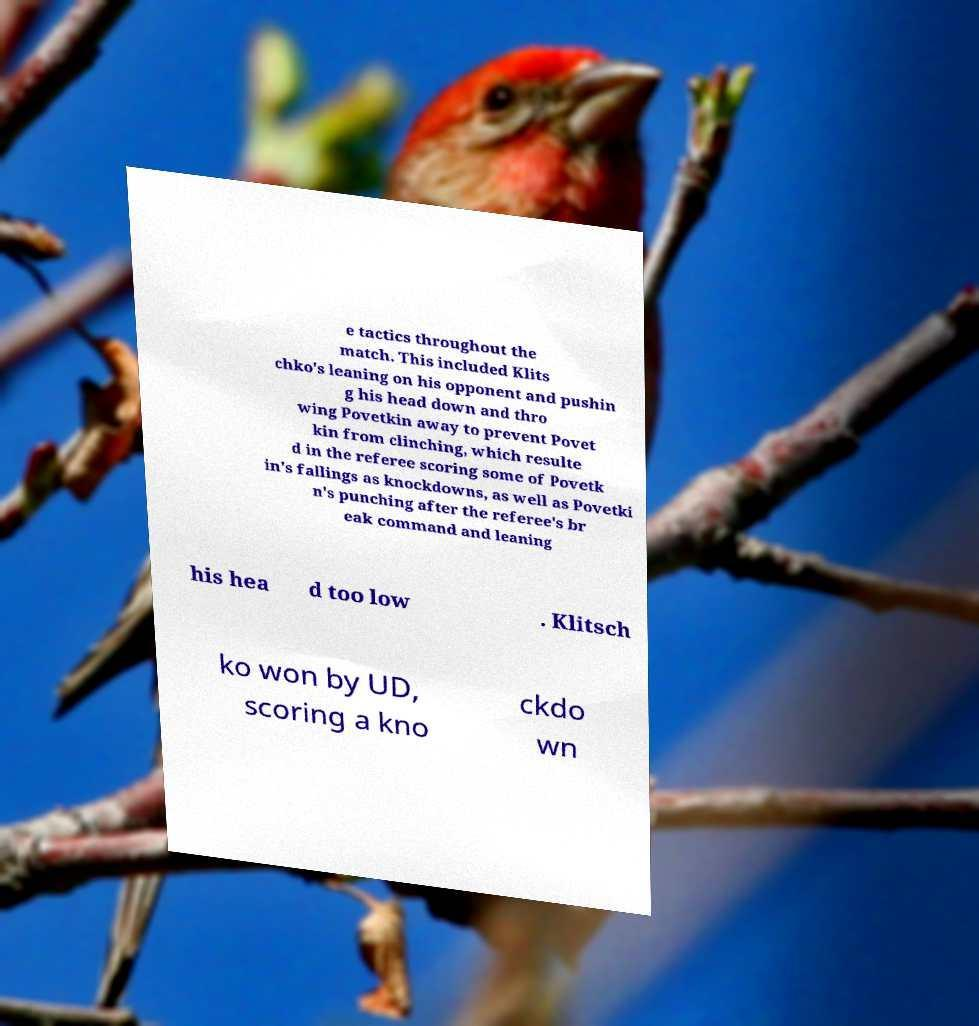Could you assist in decoding the text presented in this image and type it out clearly? e tactics throughout the match. This included Klits chko's leaning on his opponent and pushin g his head down and thro wing Povetkin away to prevent Povet kin from clinching, which resulte d in the referee scoring some of Povetk in's fallings as knockdowns, as well as Povetki n's punching after the referee's br eak command and leaning his hea d too low . Klitsch ko won by UD, scoring a kno ckdo wn 